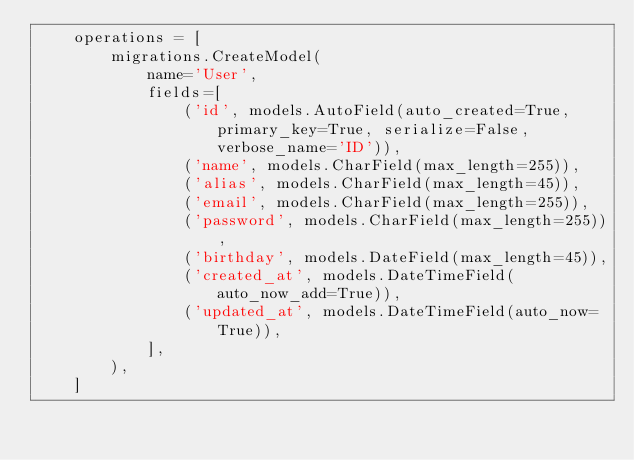Convert code to text. <code><loc_0><loc_0><loc_500><loc_500><_Python_>    operations = [
        migrations.CreateModel(
            name='User',
            fields=[
                ('id', models.AutoField(auto_created=True, primary_key=True, serialize=False, verbose_name='ID')),
                ('name', models.CharField(max_length=255)),
                ('alias', models.CharField(max_length=45)),
                ('email', models.CharField(max_length=255)),
                ('password', models.CharField(max_length=255)),
                ('birthday', models.DateField(max_length=45)),
                ('created_at', models.DateTimeField(auto_now_add=True)),
                ('updated_at', models.DateTimeField(auto_now=True)),
            ],
        ),
    ]
</code> 